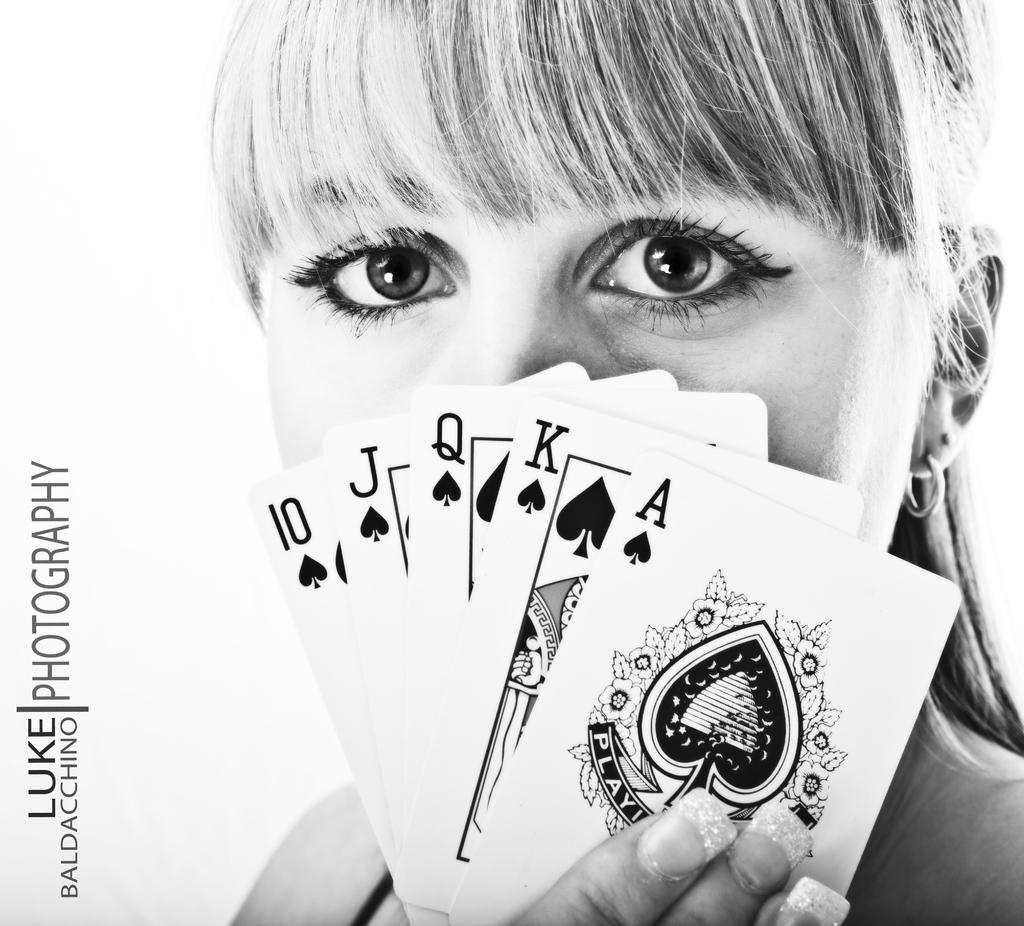Who is present in the image? There is a woman in the image. What is the woman holding in her hand? The woman is holding cards in her hand. What can be seen on the left side of the image? There is text on the left side of the image. How many legs does the rose have in the image? There is no rose present in the image, so it is not possible to determine the number of legs it might have. 